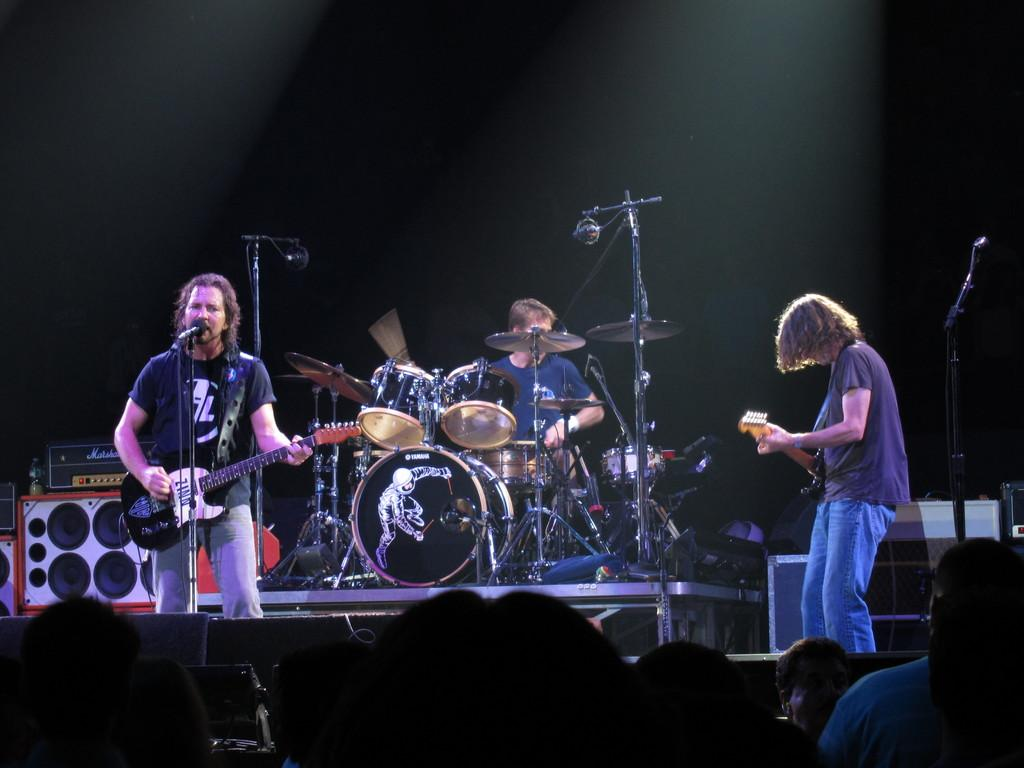What are the two persons in the image doing? The two persons are playing guitar in the image. What is the person with the guitar doing differently from the other? One of the persons is singing on a microphone. What other instrument can be seen being played in the image? There is a man playing drums in the image. Can you describe the presence of musical instruments in the image? Yes, there are musical instruments present, including guitars and drums. What is the opinion of the library on the authority of the musical performance in the image? There is no reference to a library or any opinions in the image, as it features people playing musical instruments. 